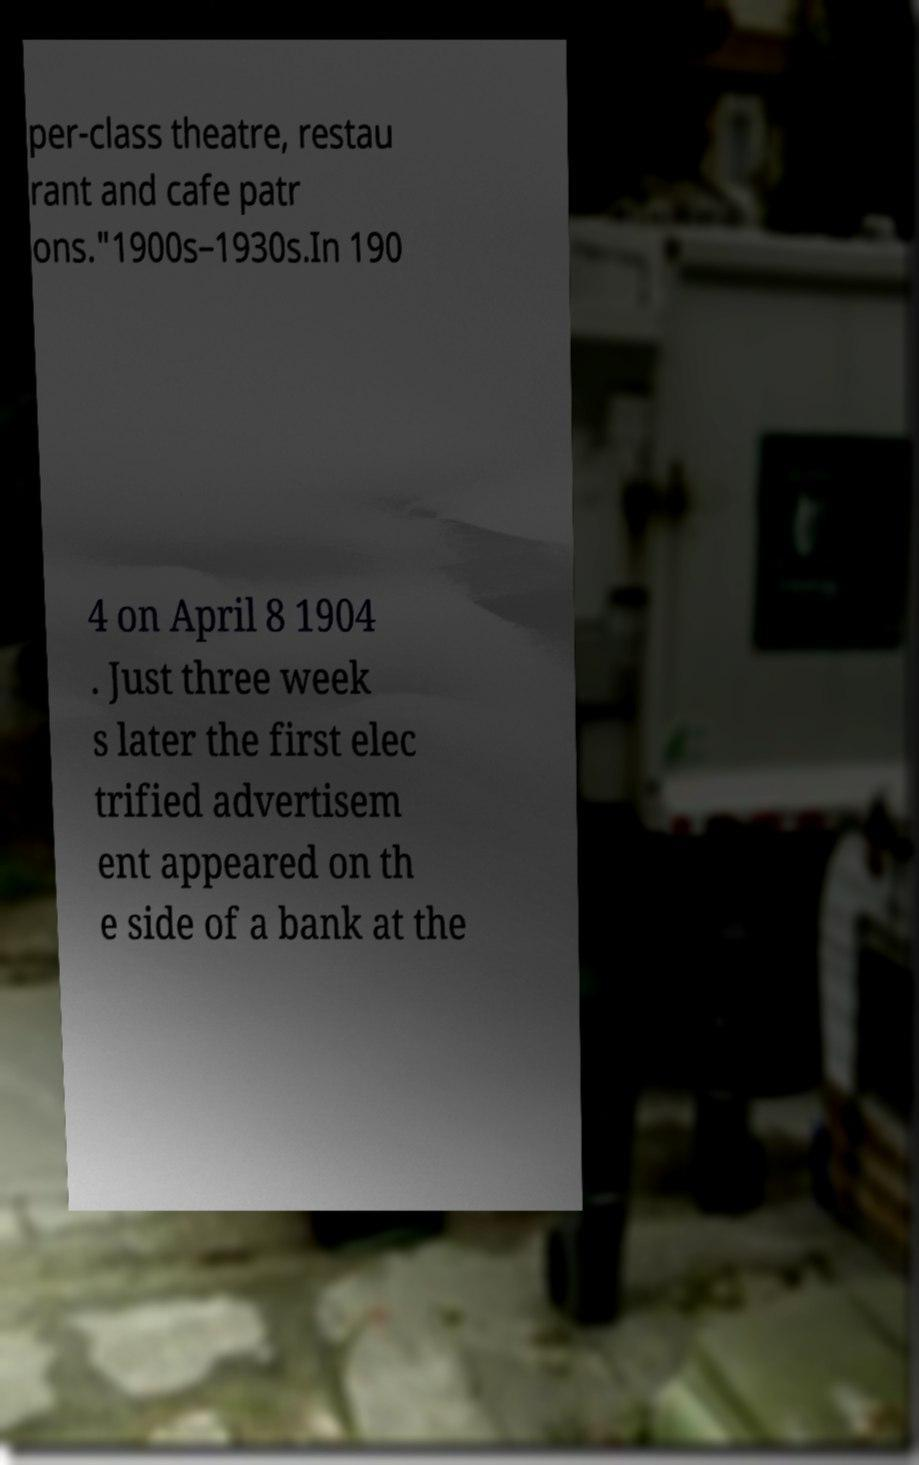Please read and relay the text visible in this image. What does it say? per-class theatre, restau rant and cafe patr ons."1900s–1930s.In 190 4 on April 8 1904 . Just three week s later the first elec trified advertisem ent appeared on th e side of a bank at the 